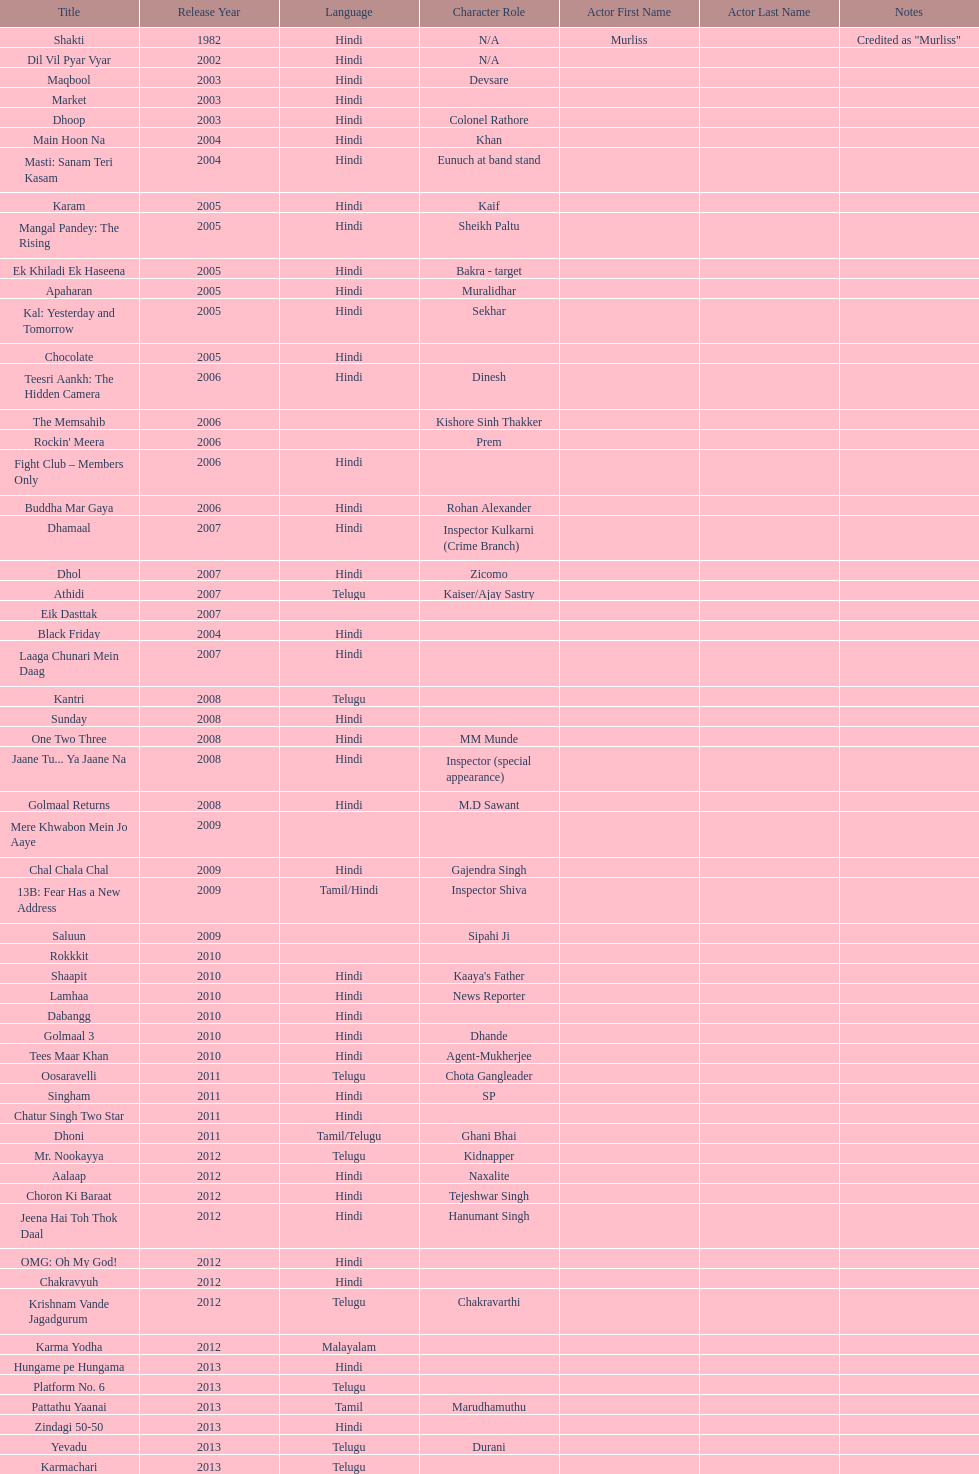What is the total years on the chart 13. 